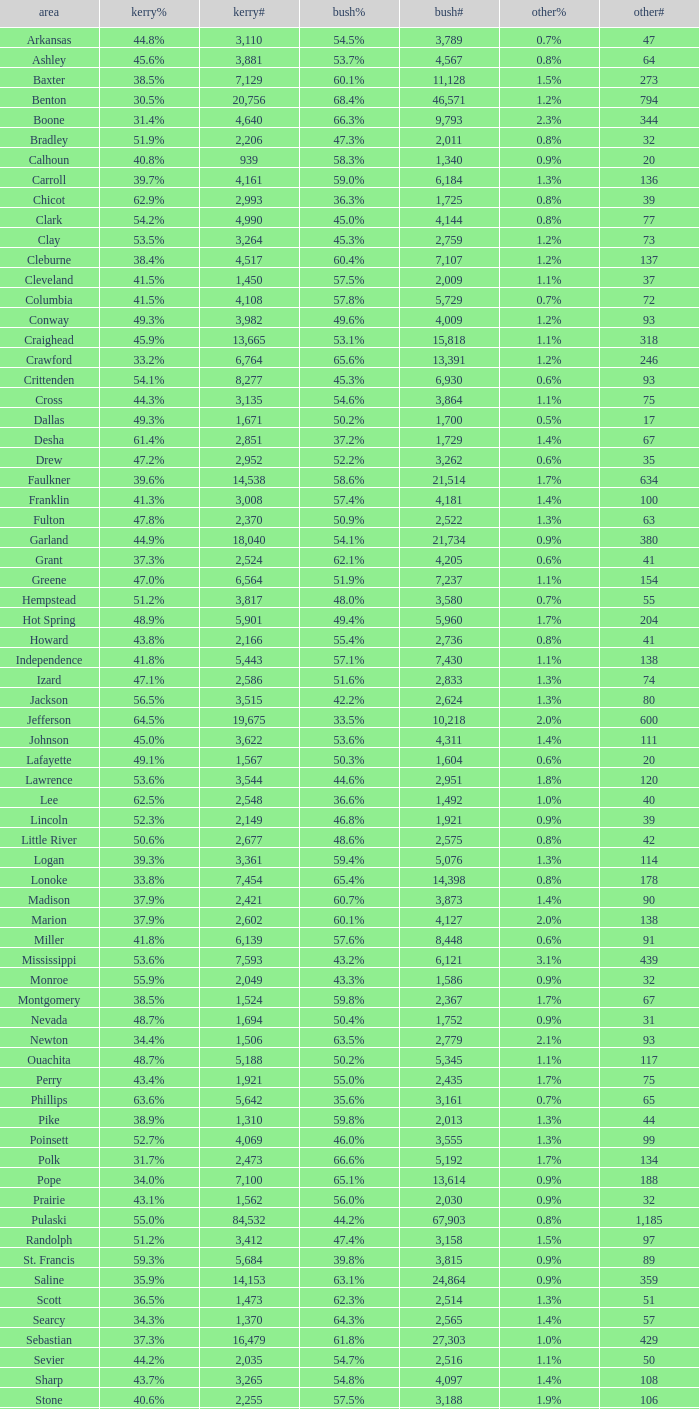What is the minimum bush# value when bush% equals "65.4%"? 14398.0. Can you give me this table as a dict? {'header': ['area', 'kerry%', 'kerry#', 'bush%', 'bush#', 'other%', 'other#'], 'rows': [['Arkansas', '44.8%', '3,110', '54.5%', '3,789', '0.7%', '47'], ['Ashley', '45.6%', '3,881', '53.7%', '4,567', '0.8%', '64'], ['Baxter', '38.5%', '7,129', '60.1%', '11,128', '1.5%', '273'], ['Benton', '30.5%', '20,756', '68.4%', '46,571', '1.2%', '794'], ['Boone', '31.4%', '4,640', '66.3%', '9,793', '2.3%', '344'], ['Bradley', '51.9%', '2,206', '47.3%', '2,011', '0.8%', '32'], ['Calhoun', '40.8%', '939', '58.3%', '1,340', '0.9%', '20'], ['Carroll', '39.7%', '4,161', '59.0%', '6,184', '1.3%', '136'], ['Chicot', '62.9%', '2,993', '36.3%', '1,725', '0.8%', '39'], ['Clark', '54.2%', '4,990', '45.0%', '4,144', '0.8%', '77'], ['Clay', '53.5%', '3,264', '45.3%', '2,759', '1.2%', '73'], ['Cleburne', '38.4%', '4,517', '60.4%', '7,107', '1.2%', '137'], ['Cleveland', '41.5%', '1,450', '57.5%', '2,009', '1.1%', '37'], ['Columbia', '41.5%', '4,108', '57.8%', '5,729', '0.7%', '72'], ['Conway', '49.3%', '3,982', '49.6%', '4,009', '1.2%', '93'], ['Craighead', '45.9%', '13,665', '53.1%', '15,818', '1.1%', '318'], ['Crawford', '33.2%', '6,764', '65.6%', '13,391', '1.2%', '246'], ['Crittenden', '54.1%', '8,277', '45.3%', '6,930', '0.6%', '93'], ['Cross', '44.3%', '3,135', '54.6%', '3,864', '1.1%', '75'], ['Dallas', '49.3%', '1,671', '50.2%', '1,700', '0.5%', '17'], ['Desha', '61.4%', '2,851', '37.2%', '1,729', '1.4%', '67'], ['Drew', '47.2%', '2,952', '52.2%', '3,262', '0.6%', '35'], ['Faulkner', '39.6%', '14,538', '58.6%', '21,514', '1.7%', '634'], ['Franklin', '41.3%', '3,008', '57.4%', '4,181', '1.4%', '100'], ['Fulton', '47.8%', '2,370', '50.9%', '2,522', '1.3%', '63'], ['Garland', '44.9%', '18,040', '54.1%', '21,734', '0.9%', '380'], ['Grant', '37.3%', '2,524', '62.1%', '4,205', '0.6%', '41'], ['Greene', '47.0%', '6,564', '51.9%', '7,237', '1.1%', '154'], ['Hempstead', '51.2%', '3,817', '48.0%', '3,580', '0.7%', '55'], ['Hot Spring', '48.9%', '5,901', '49.4%', '5,960', '1.7%', '204'], ['Howard', '43.8%', '2,166', '55.4%', '2,736', '0.8%', '41'], ['Independence', '41.8%', '5,443', '57.1%', '7,430', '1.1%', '138'], ['Izard', '47.1%', '2,586', '51.6%', '2,833', '1.3%', '74'], ['Jackson', '56.5%', '3,515', '42.2%', '2,624', '1.3%', '80'], ['Jefferson', '64.5%', '19,675', '33.5%', '10,218', '2.0%', '600'], ['Johnson', '45.0%', '3,622', '53.6%', '4,311', '1.4%', '111'], ['Lafayette', '49.1%', '1,567', '50.3%', '1,604', '0.6%', '20'], ['Lawrence', '53.6%', '3,544', '44.6%', '2,951', '1.8%', '120'], ['Lee', '62.5%', '2,548', '36.6%', '1,492', '1.0%', '40'], ['Lincoln', '52.3%', '2,149', '46.8%', '1,921', '0.9%', '39'], ['Little River', '50.6%', '2,677', '48.6%', '2,575', '0.8%', '42'], ['Logan', '39.3%', '3,361', '59.4%', '5,076', '1.3%', '114'], ['Lonoke', '33.8%', '7,454', '65.4%', '14,398', '0.8%', '178'], ['Madison', '37.9%', '2,421', '60.7%', '3,873', '1.4%', '90'], ['Marion', '37.9%', '2,602', '60.1%', '4,127', '2.0%', '138'], ['Miller', '41.8%', '6,139', '57.6%', '8,448', '0.6%', '91'], ['Mississippi', '53.6%', '7,593', '43.2%', '6,121', '3.1%', '439'], ['Monroe', '55.9%', '2,049', '43.3%', '1,586', '0.9%', '32'], ['Montgomery', '38.5%', '1,524', '59.8%', '2,367', '1.7%', '67'], ['Nevada', '48.7%', '1,694', '50.4%', '1,752', '0.9%', '31'], ['Newton', '34.4%', '1,506', '63.5%', '2,779', '2.1%', '93'], ['Ouachita', '48.7%', '5,188', '50.2%', '5,345', '1.1%', '117'], ['Perry', '43.4%', '1,921', '55.0%', '2,435', '1.7%', '75'], ['Phillips', '63.6%', '5,642', '35.6%', '3,161', '0.7%', '65'], ['Pike', '38.9%', '1,310', '59.8%', '2,013', '1.3%', '44'], ['Poinsett', '52.7%', '4,069', '46.0%', '3,555', '1.3%', '99'], ['Polk', '31.7%', '2,473', '66.6%', '5,192', '1.7%', '134'], ['Pope', '34.0%', '7,100', '65.1%', '13,614', '0.9%', '188'], ['Prairie', '43.1%', '1,562', '56.0%', '2,030', '0.9%', '32'], ['Pulaski', '55.0%', '84,532', '44.2%', '67,903', '0.8%', '1,185'], ['Randolph', '51.2%', '3,412', '47.4%', '3,158', '1.5%', '97'], ['St. Francis', '59.3%', '5,684', '39.8%', '3,815', '0.9%', '89'], ['Saline', '35.9%', '14,153', '63.1%', '24,864', '0.9%', '359'], ['Scott', '36.5%', '1,473', '62.3%', '2,514', '1.3%', '51'], ['Searcy', '34.3%', '1,370', '64.3%', '2,565', '1.4%', '57'], ['Sebastian', '37.3%', '16,479', '61.8%', '27,303', '1.0%', '429'], ['Sevier', '44.2%', '2,035', '54.7%', '2,516', '1.1%', '50'], ['Sharp', '43.7%', '3,265', '54.8%', '4,097', '1.4%', '108'], ['Stone', '40.6%', '2,255', '57.5%', '3,188', '1.9%', '106'], ['Union', '39.7%', '7,071', '58.9%', '10,502', '1.5%', '259'], ['Van Buren', '44.9%', '3,310', '54.1%', '3,988', '1.0%', '76'], ['Washington', '43.1%', '27,597', '55.7%', '35,726', '1.2%', '780'], ['White', '34.5%', '9,129', '64.3%', '17,001', '1.1%', '295'], ['Woodruff', '65.2%', '1,972', '33.7%', '1,021', '1.1%', '33'], ['Yell', '43.7%', '2,913', '55.2%', '3,678', '1.0%', '68']]} 